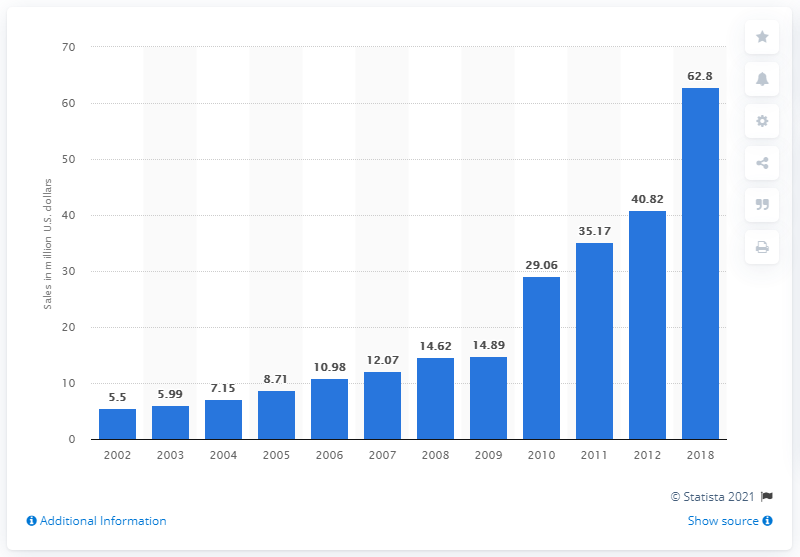Draw attention to some important aspects in this diagram. The value of the fine jewelry market in India in 2018 was approximately 62.8 billion rupees. 